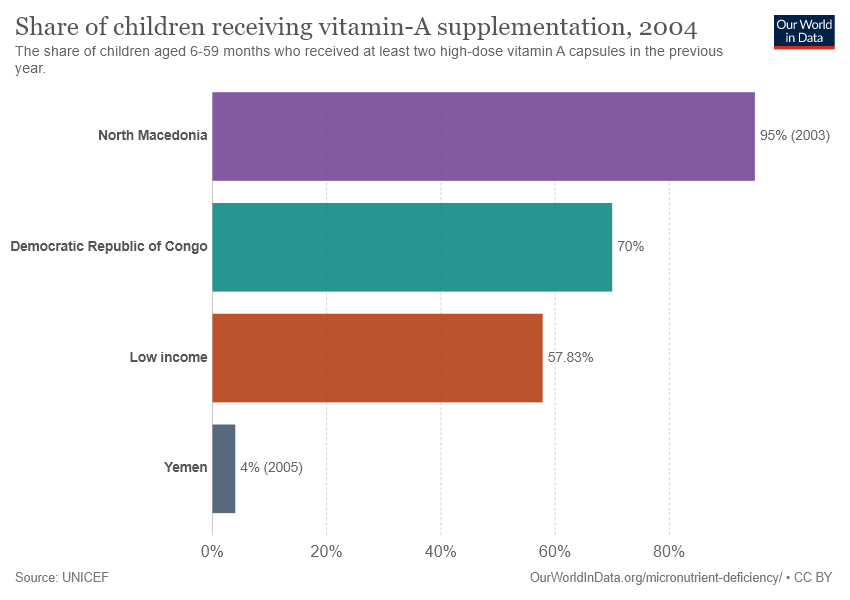Highlight a few significant elements in this photo. The difference between the second largest and second smallest bar is greater than the value of the smallest bar. There are 4 bars in the graph. 